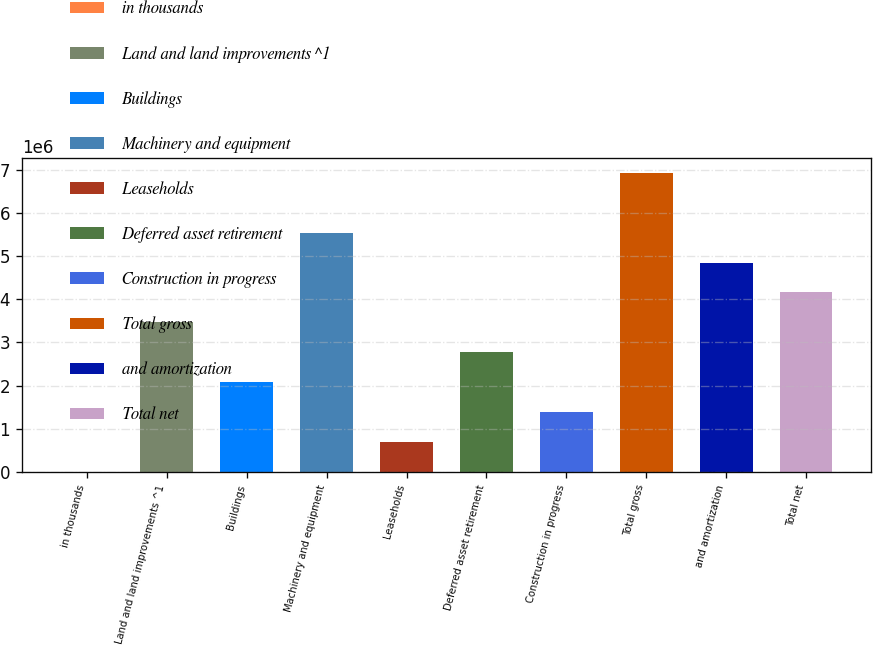Convert chart to OTSL. <chart><loc_0><loc_0><loc_500><loc_500><bar_chart><fcel>in thousands<fcel>Land and land improvements ^1<fcel>Buildings<fcel>Machinery and equipment<fcel>Leaseholds<fcel>Deferred asset retirement<fcel>Construction in progress<fcel>Total gross<fcel>and amortization<fcel>Total net<nl><fcel>2013<fcel>3.46781e+06<fcel>2.08149e+06<fcel>5.54728e+06<fcel>695172<fcel>2.77465e+06<fcel>1.38833e+06<fcel>6.9336e+06<fcel>4.85413e+06<fcel>4.16097e+06<nl></chart> 